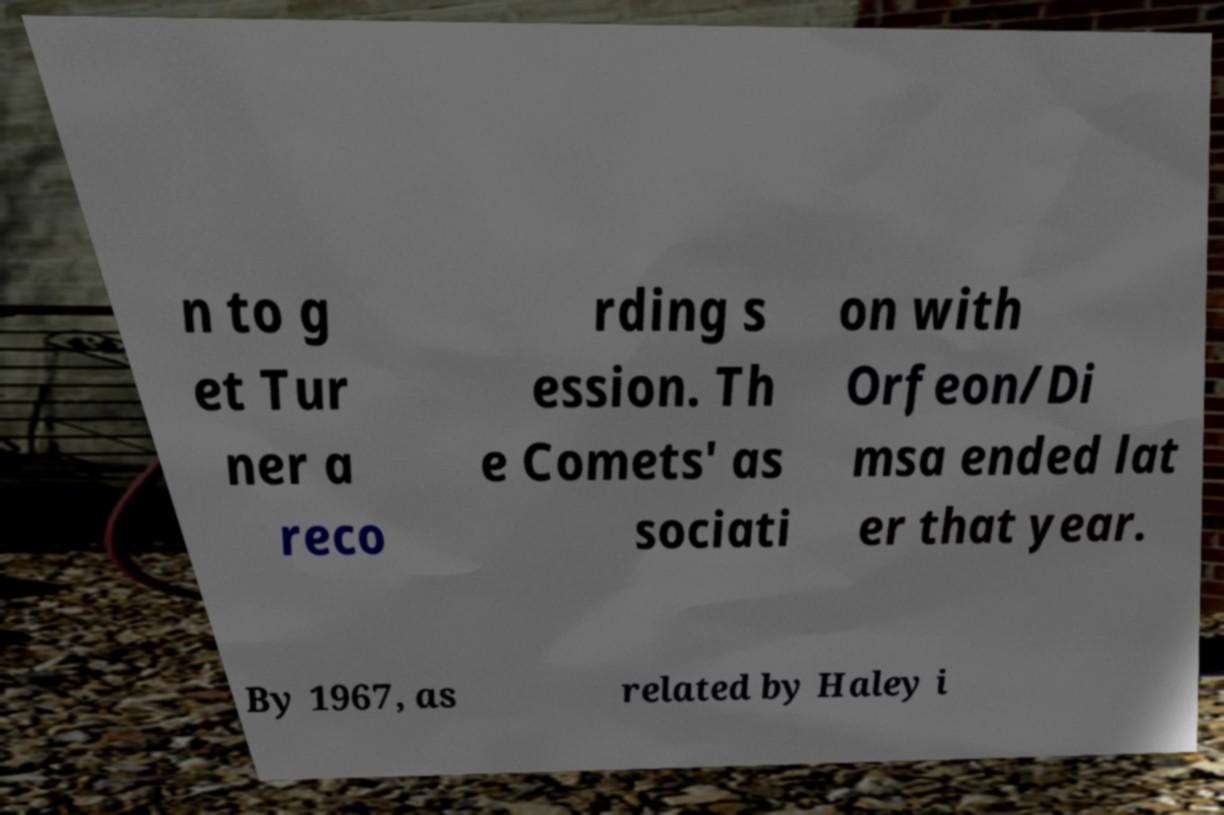I need the written content from this picture converted into text. Can you do that? n to g et Tur ner a reco rding s ession. Th e Comets' as sociati on with Orfeon/Di msa ended lat er that year. By 1967, as related by Haley i 